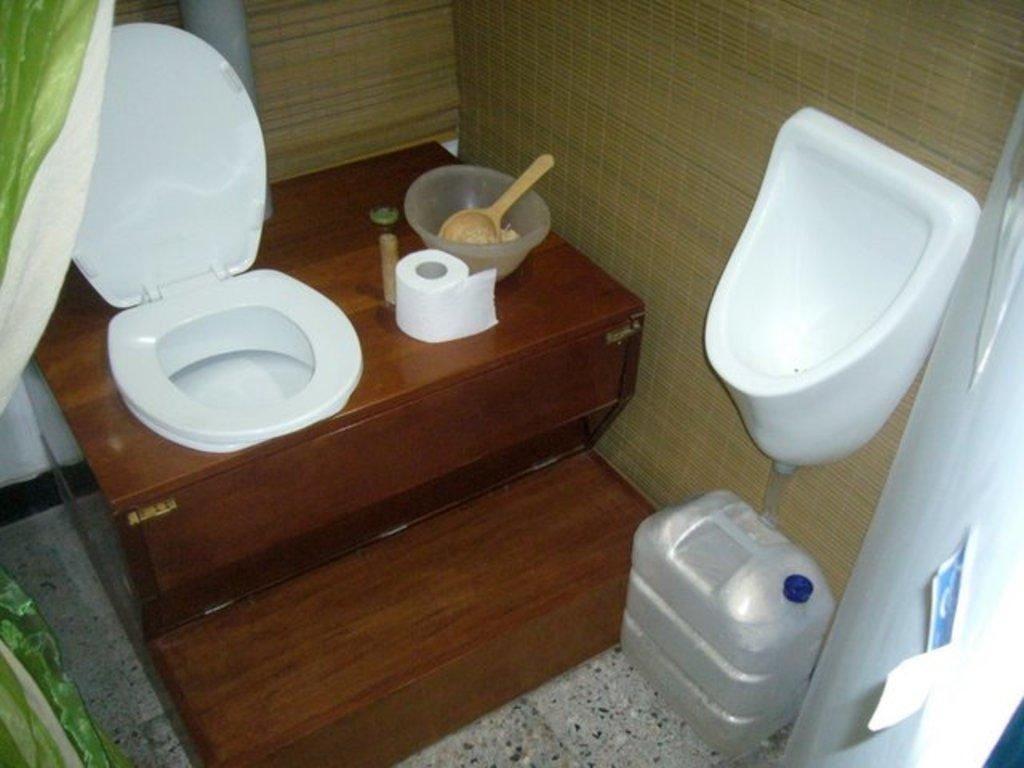What is the primary object in the image? There is a toilet seat in the image. What can be seen near the toilet seat? There is a tissue paper roll and a water can on the floor in the image. What is placed inside the bowl in the image? There is a spoon in the bowl in the image. What type of covering is present in the image? There is a curtain in the image. What type of structure is visible in the background? There is a wall in the image. What is the main purpose of the room depicted in the image? The room contains a commode, suggesting it is a bathroom. Can you see a swing in the image? No, there is no swing present in the image. Is there a cannon visible in the image? No, there is no cannon present in the image. 